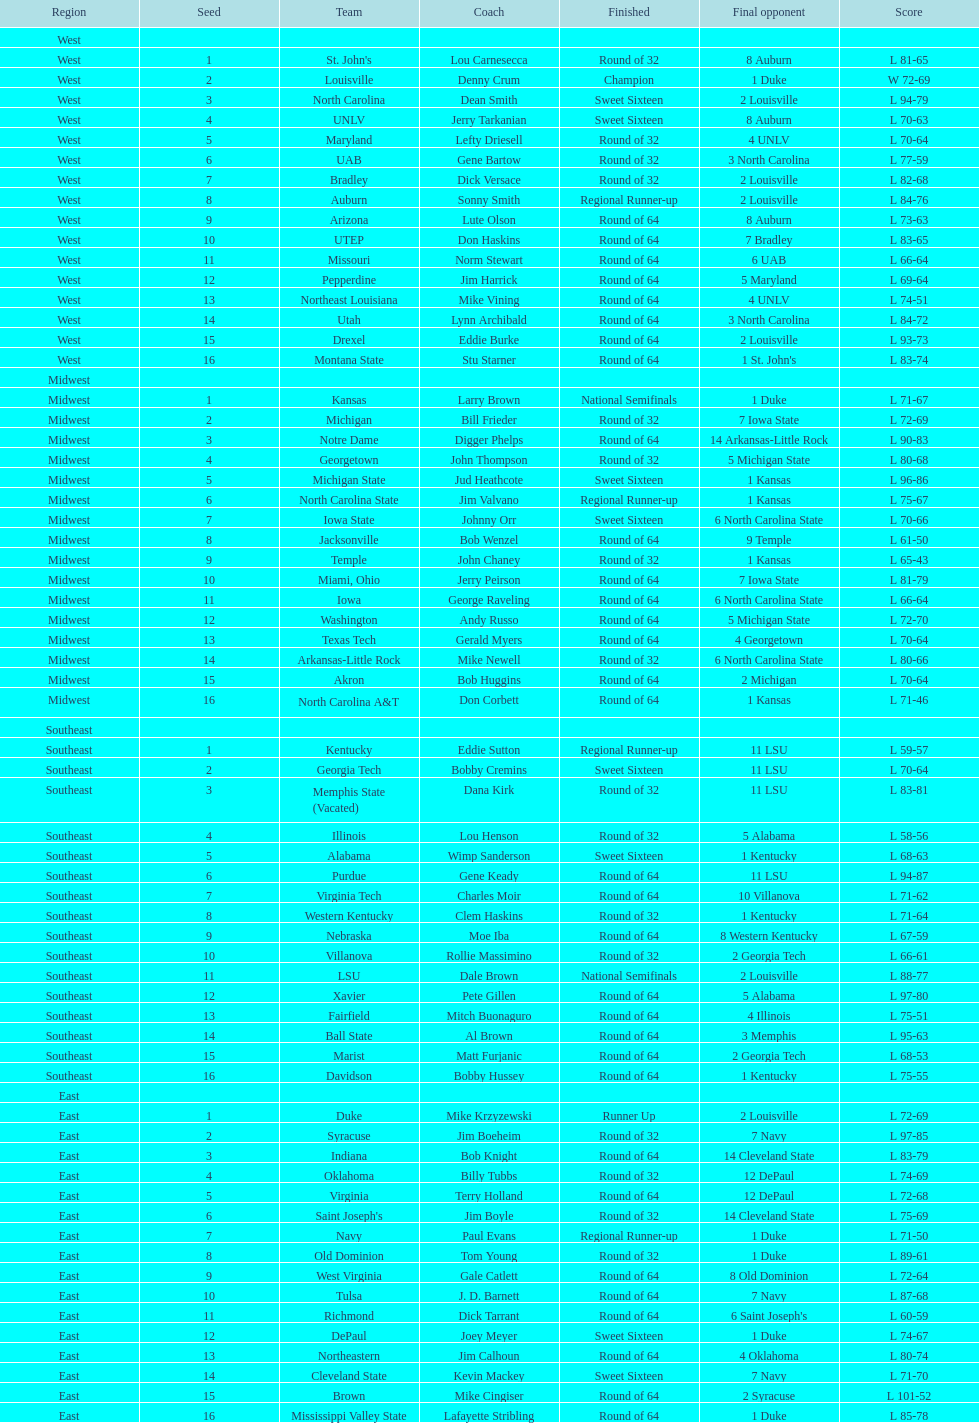What region is listed before the midwest? West. 